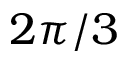<formula> <loc_0><loc_0><loc_500><loc_500>2 \pi / 3</formula> 